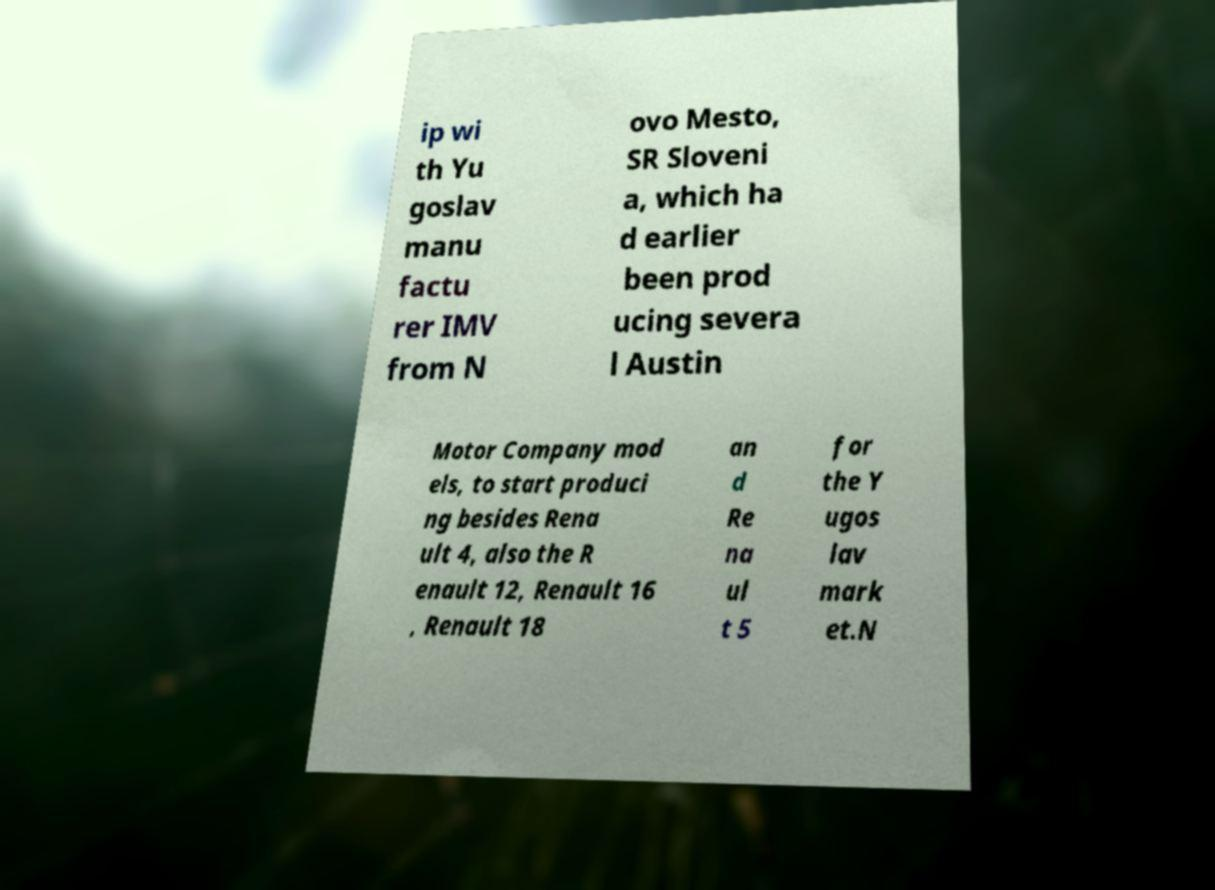Could you assist in decoding the text presented in this image and type it out clearly? ip wi th Yu goslav manu factu rer IMV from N ovo Mesto, SR Sloveni a, which ha d earlier been prod ucing severa l Austin Motor Company mod els, to start produci ng besides Rena ult 4, also the R enault 12, Renault 16 , Renault 18 an d Re na ul t 5 for the Y ugos lav mark et.N 